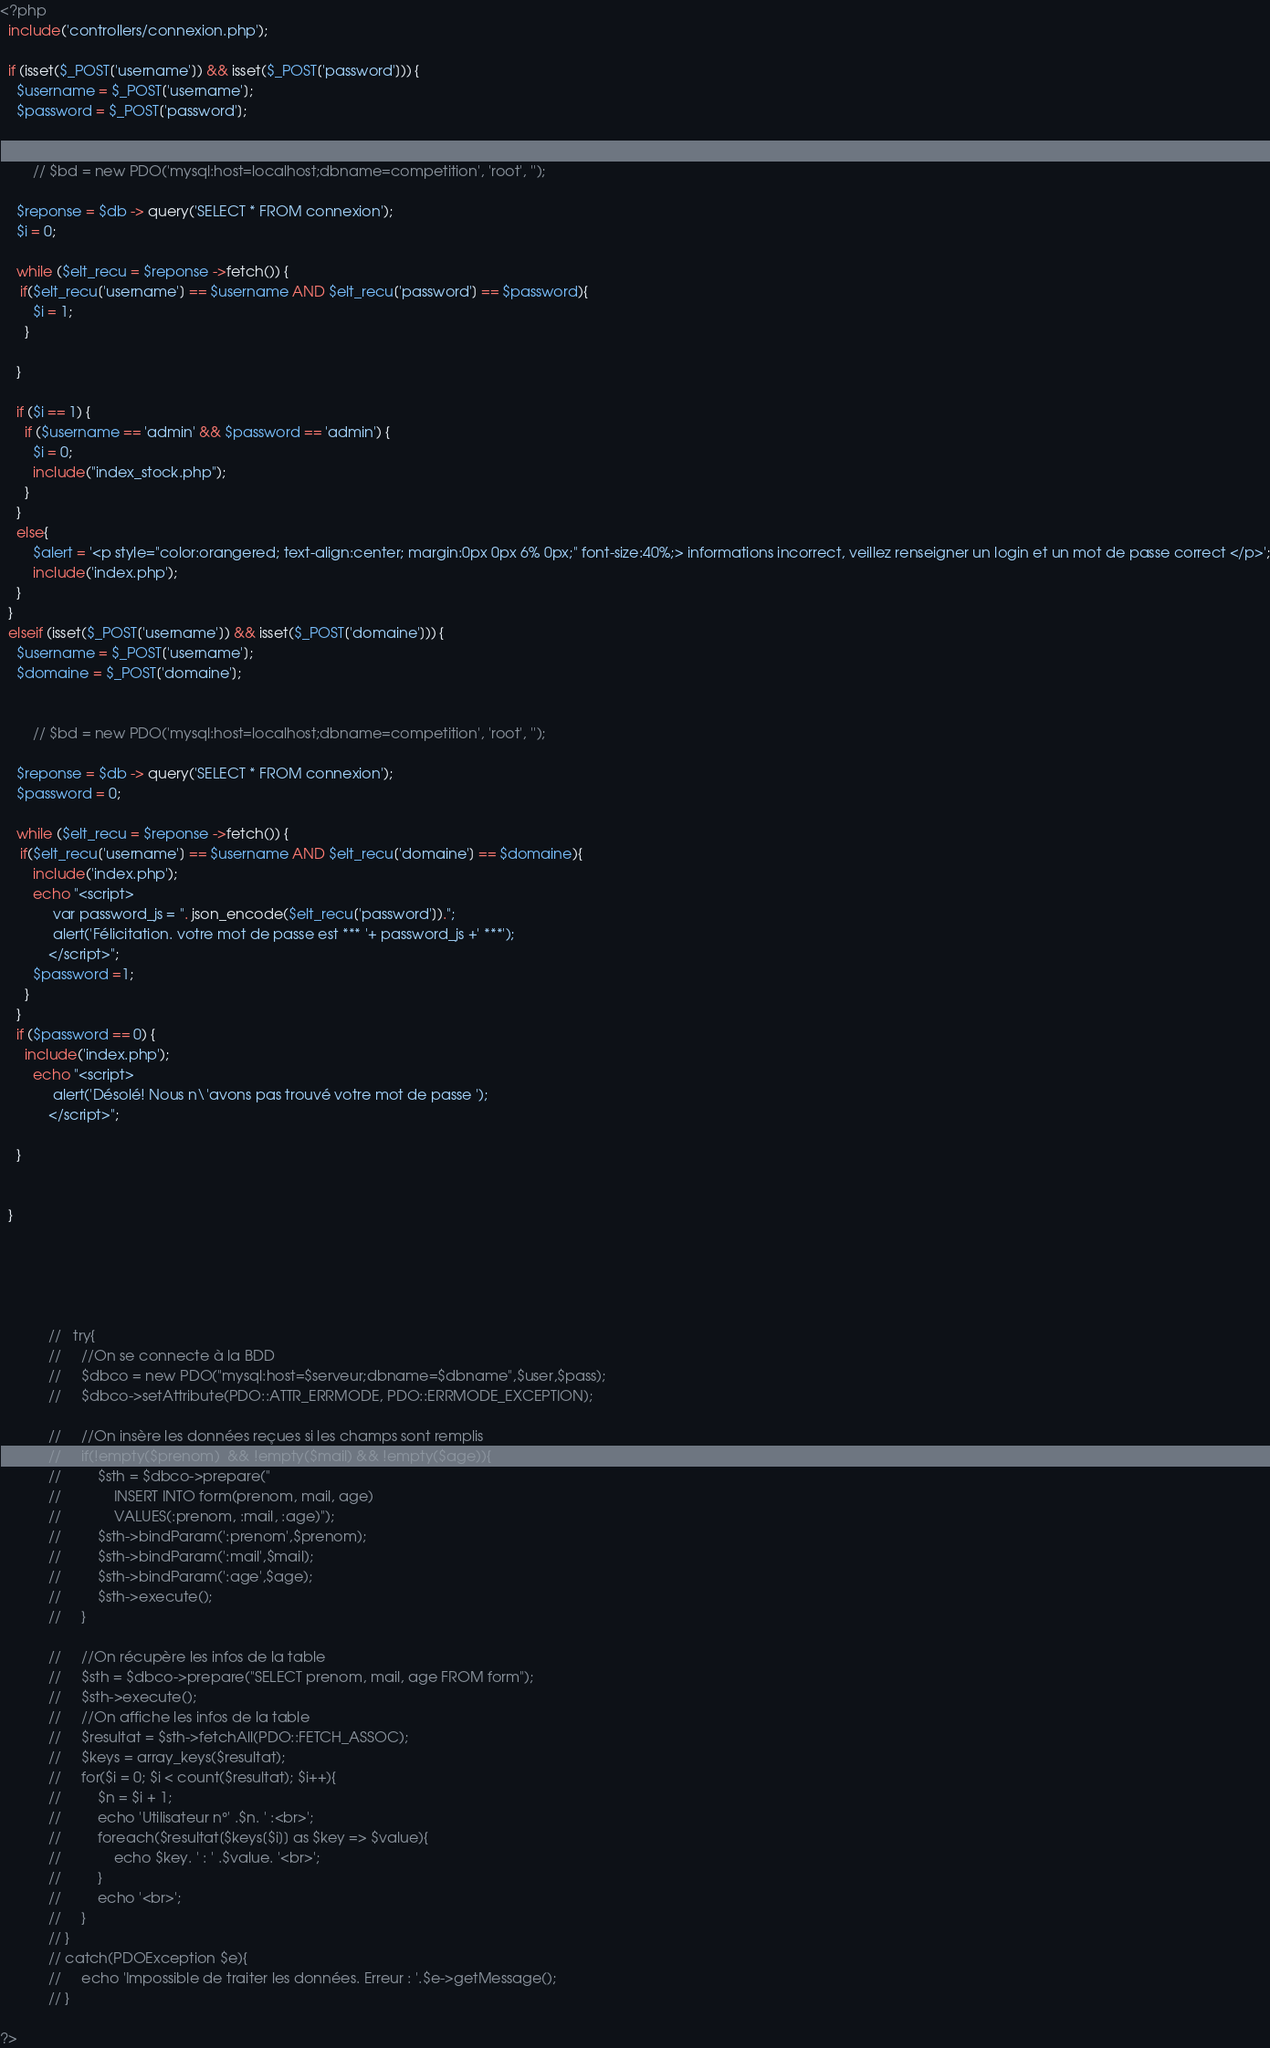Convert code to text. <code><loc_0><loc_0><loc_500><loc_500><_PHP_><?php
  include('controllers/connexion.php');

  if (isset($_POST['username']) && isset($_POST['password'])) {
    $username = $_POST['username'];
    $password = $_POST['password'];


        // $bd = new PDO('mysql:host=localhost;dbname=competition', 'root', '');

    $reponse = $db -> query('SELECT * FROM connexion');
    $i = 0;

    while ($elt_recu = $reponse ->fetch()) {
     if($elt_recu['username'] == $username AND $elt_recu['password'] == $password){
        $i = 1;
      }

    }

    if ($i == 1) {
      if ($username == 'admin' && $password == 'admin') {
        $i = 0;
        include("index_stock.php");
      }
    }
    else{
        $alert = '<p style="color:orangered; text-align:center; margin:0px 0px 6% 0px;" font-size:40%;> informations incorrect, veillez renseigner un login et un mot de passe correct </p>';
        include('index.php');
    }
  }
  elseif (isset($_POST['username']) && isset($_POST['domaine'])) {
    $username = $_POST['username'];
    $domaine = $_POST['domaine'];


        // $bd = new PDO('mysql:host=localhost;dbname=competition', 'root', '');

    $reponse = $db -> query('SELECT * FROM connexion');
    $password = 0;

    while ($elt_recu = $reponse ->fetch()) {
     if($elt_recu['username'] == $username AND $elt_recu['domaine'] == $domaine){
        include('index.php');
        echo "<script>
             var password_js = ". json_encode($elt_recu['password']).";
             alert('Félicitation. votre mot de passe est *** '+ password_js +' ***');
            </script>";
        $password =1;
      }
    }
    if ($password == 0) {
      include('index.php');
        echo "<script>
             alert('Désolé! Nous n\'avons pas trouvé votre mot de passe ');
            </script>";

    }


  }





            //   try{
            //     //On se connecte à la BDD
            //     $dbco = new PDO("mysql:host=$serveur;dbname=$dbname",$user,$pass);
            //     $dbco->setAttribute(PDO::ATTR_ERRMODE, PDO::ERRMODE_EXCEPTION);

            //     //On insère les données reçues si les champs sont remplis
            //     if(!empty($prenom)  && !empty($mail) && !empty($age)){
            //         $sth = $dbco->prepare("
            //             INSERT INTO form(prenom, mail, age)
            //             VALUES(:prenom, :mail, :age)");
            //         $sth->bindParam(':prenom',$prenom);
            //         $sth->bindParam(':mail',$mail);
            //         $sth->bindParam(':age',$age);
            //         $sth->execute();
            //     }

            //     //On récupère les infos de la table
            //     $sth = $dbco->prepare("SELECT prenom, mail, age FROM form");
            //     $sth->execute();
            //     //On affiche les infos de la table
            //     $resultat = $sth->fetchAll(PDO::FETCH_ASSOC);
            //     $keys = array_keys($resultat);
            //     for($i = 0; $i < count($resultat); $i++){
            //         $n = $i + 1;
            //         echo 'Utilisateur n°' .$n. ' :<br>';
            //         foreach($resultat[$keys[$i]] as $key => $value){
            //             echo $key. ' : ' .$value. '<br>';
            //         }
            //         echo '<br>';
            //     }
            // }
            // catch(PDOException $e){
            //     echo 'Impossible de traiter les données. Erreur : '.$e->getMessage();
            // }

?>
</code> 